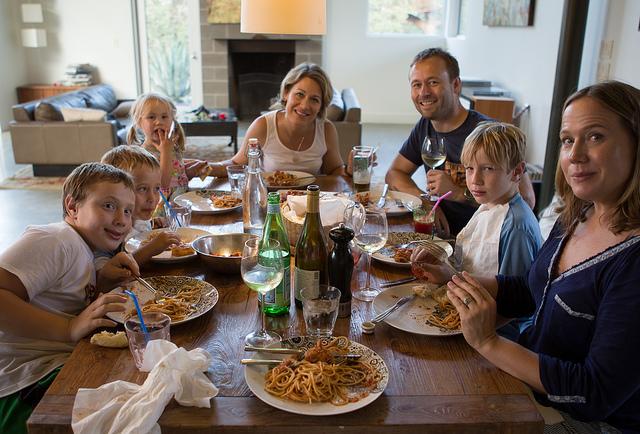What are they posing for?
Answer briefly. Picture. What is on the plates?
Write a very short answer. Spaghetti. Is this a large family?
Short answer required. Yes. 